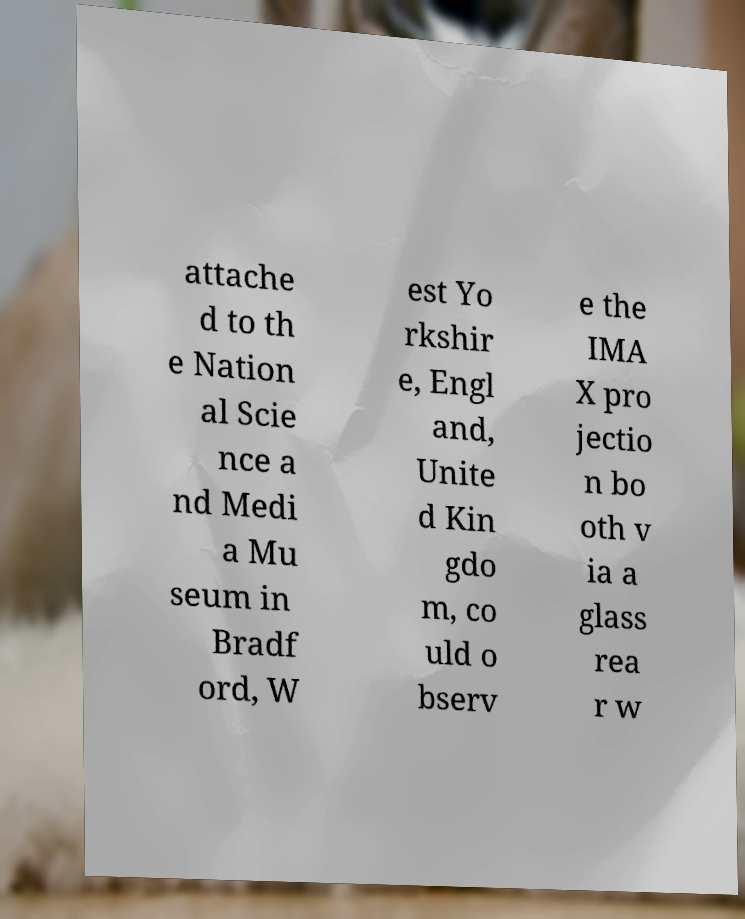Could you assist in decoding the text presented in this image and type it out clearly? attache d to th e Nation al Scie nce a nd Medi a Mu seum in Bradf ord, W est Yo rkshir e, Engl and, Unite d Kin gdo m, co uld o bserv e the IMA X pro jectio n bo oth v ia a glass rea r w 